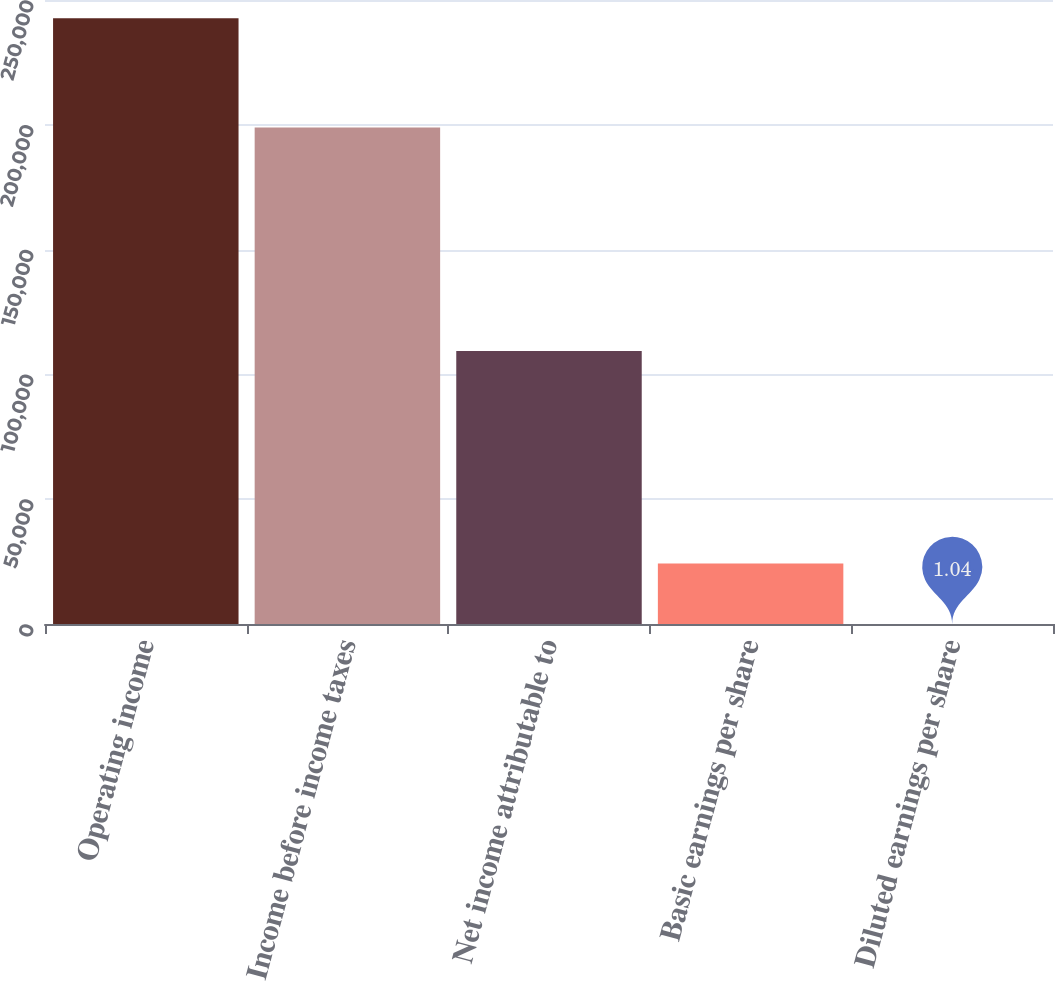<chart> <loc_0><loc_0><loc_500><loc_500><bar_chart><fcel>Operating income<fcel>Income before income taxes<fcel>Net income attributable to<fcel>Basic earnings per share<fcel>Diluted earnings per share<nl><fcel>242666<fcel>198914<fcel>109423<fcel>24267.5<fcel>1.04<nl></chart> 